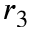<formula> <loc_0><loc_0><loc_500><loc_500>r _ { 3 }</formula> 